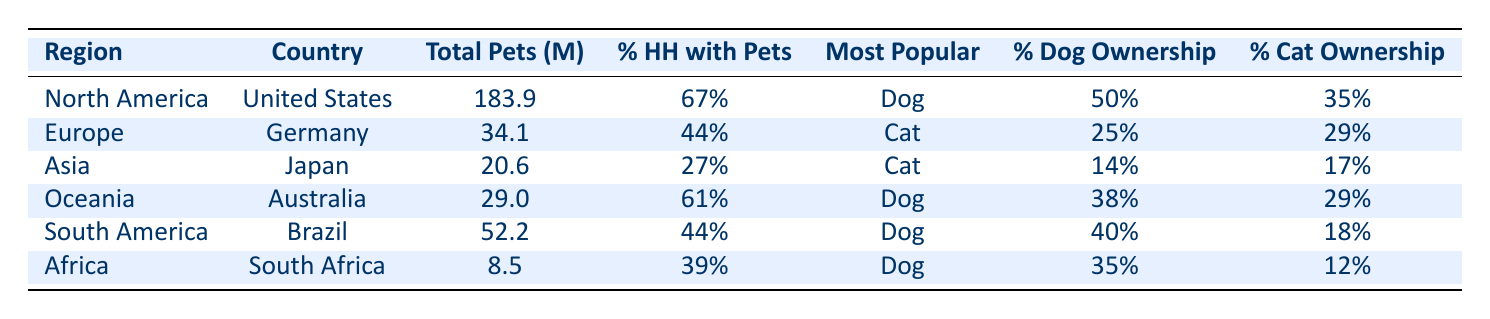What is the total number of pets in North America? The table shows that the total pets in North America (specifically in the United States) is listed as 183.9 million.
Answer: 183.9 million Which region has the highest percentage of households with pets? By comparing the percentage of households with pets across the regions listed (67% in North America, 44% in Europe, 27% in Asia, 61% in Oceania, 44% in South America, and 39% in Africa), North America has the highest percentage at 67%.
Answer: North America What is the most popular pet in Germany? The table specifically lists Germany under Europe with Cat as the most popular pet.
Answer: Cat How many more dogs are owned in Brazil compared to Japan? The dog ownership percentage is 40% in Brazil and 14% in Japan. To find the difference, subtract the percentage of Japan from Brazil: 40% - 14% = 26%.
Answer: 26% Is cat ownership percentage in Australia greater than in Germany? The cat ownership percentage is 29% in Australia and 29% in Germany. Since both percentages are equal, the statement is false.
Answer: No What is the average percentage of households with pets across all regions? To find the average, sum the percentages: 67% (North America) + 44% (Europe) + 27% (Asia) + 61% (Oceania) + 44% (South America) + 39% (Africa) = 282%. There are 6 regions, so the average is 282% / 6 = 47%.
Answer: 47% Which country has the lowest total pets and what is the amount? By examining the total pets column, South Africa is listed with the lowest total at 8.5 million pets.
Answer: 8.5 million Do more households have pets in Australia than in Japan? Australia has 61% of households with pets, while Japan has 27%. Since 61% is greater than 27%, this statement is true.
Answer: Yes What region has the highest dog ownership percentage and what is it? Checking the table, North America shows a dog ownership percentage of 50%, which is the highest compared to 25% in Germany, 14% in Japan, 38% in Australia, 40% in Brazil, and 35% in South Africa.
Answer: North America, 50% 